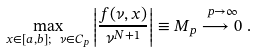<formula> <loc_0><loc_0><loc_500><loc_500>\max _ { x \in [ a , b ] ; \ \nu \in C _ { p } } \left | \frac { f ( \nu , x ) } { \nu ^ { N + 1 } } \right | \equiv M _ { p } \stackrel { p \rightarrow \infty } { \longrightarrow 0 } .</formula> 